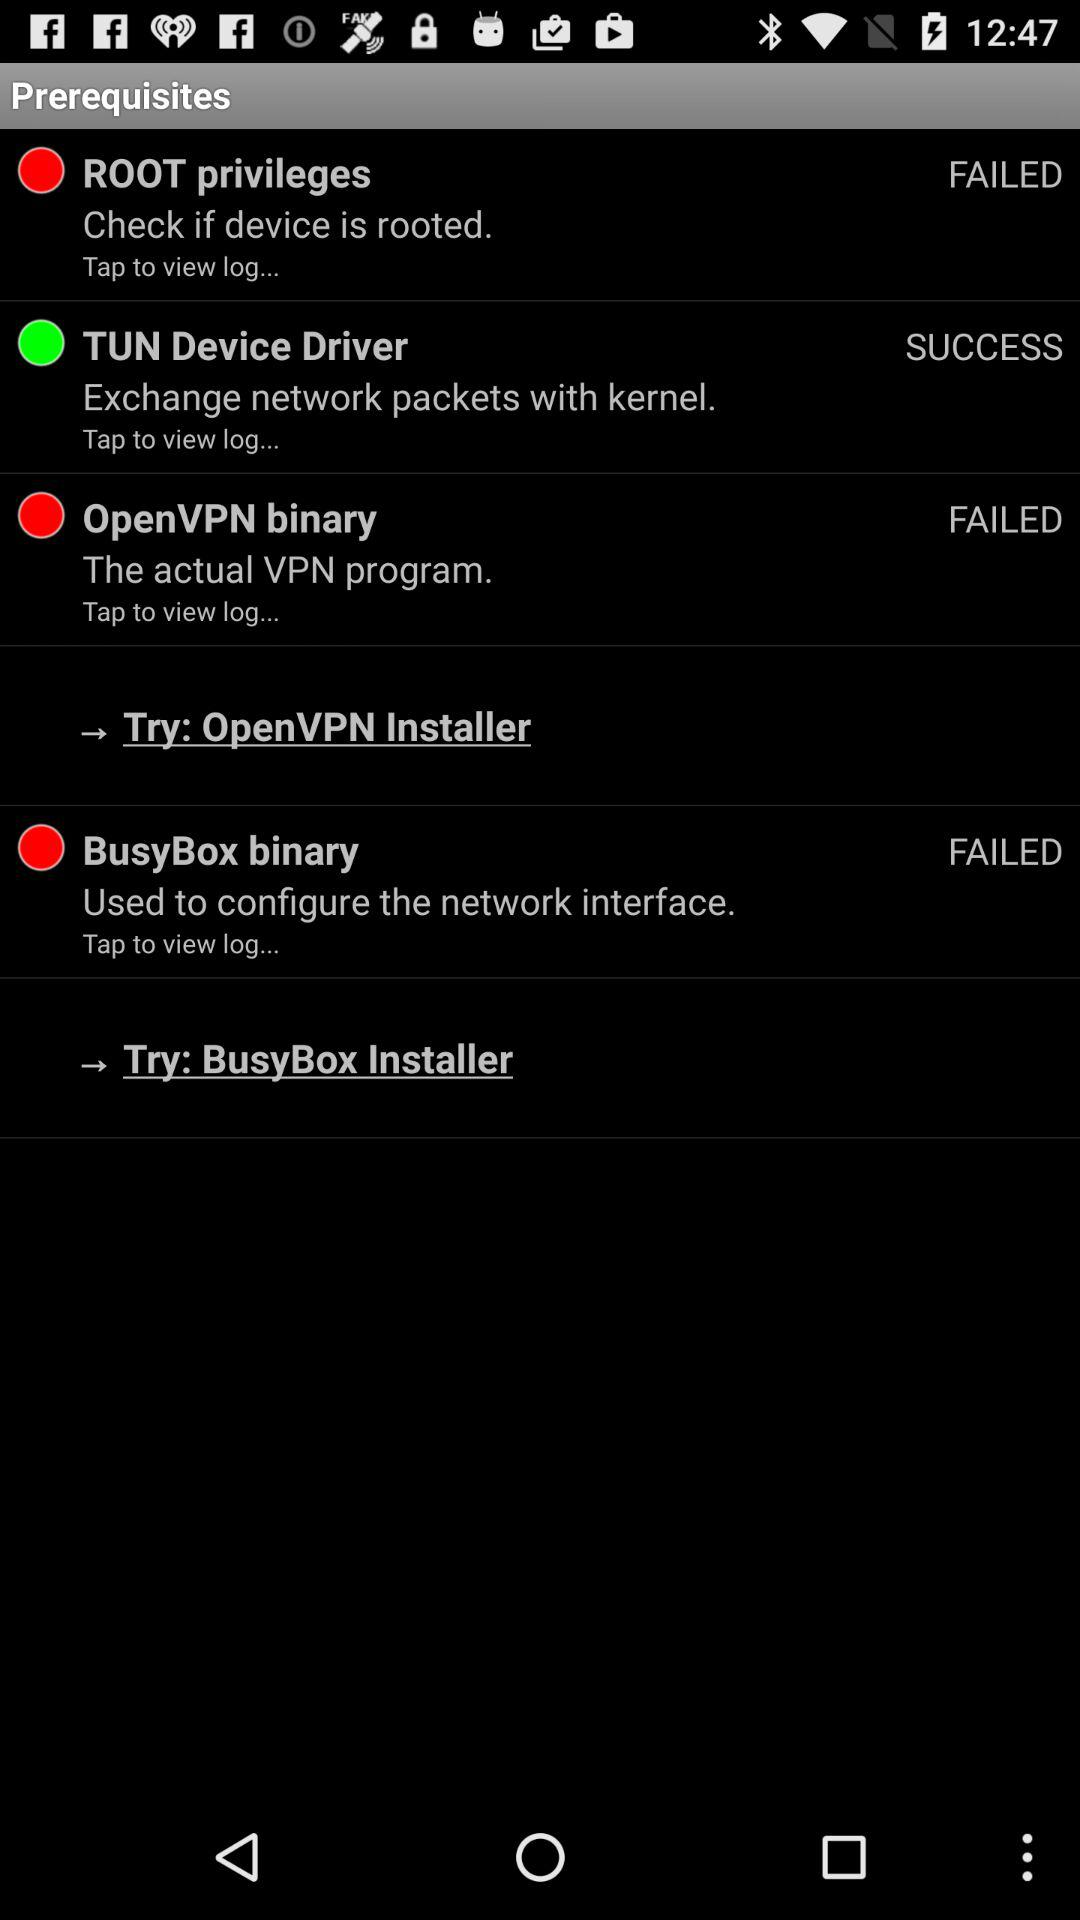Is the "OpenVPN binary" program failed or successful? The "OpenVPN binary" program is failed. 